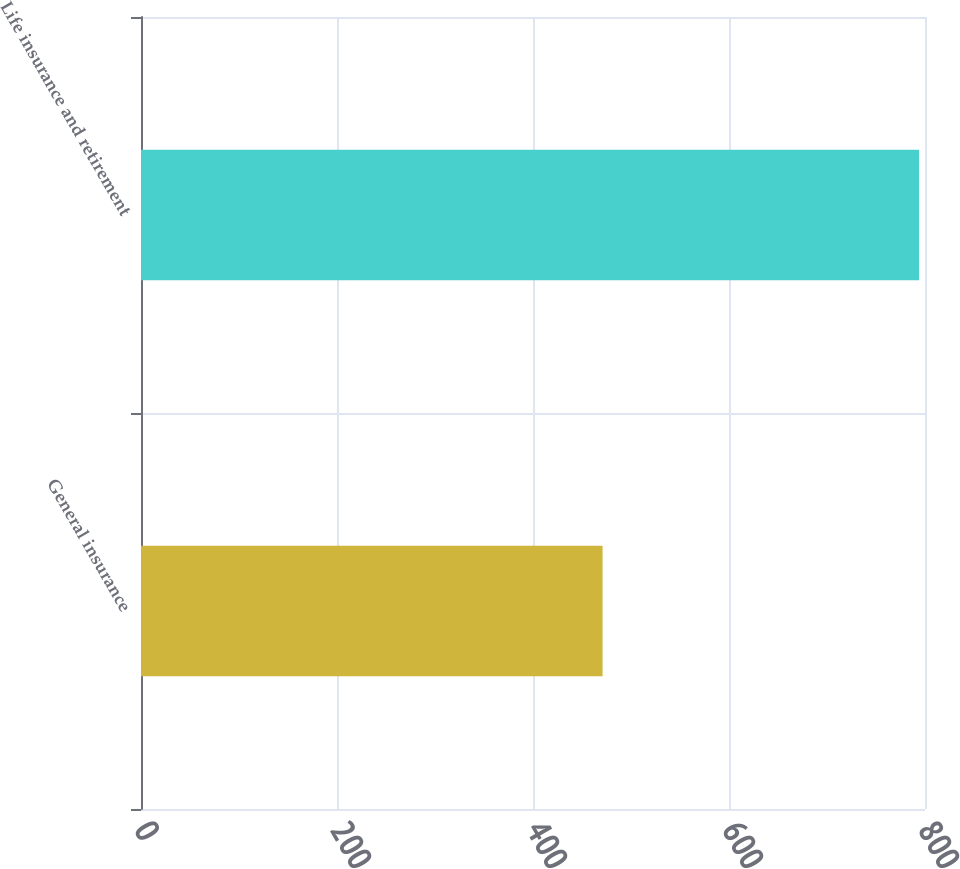Convert chart. <chart><loc_0><loc_0><loc_500><loc_500><bar_chart><fcel>General insurance<fcel>Life insurance and retirement<nl><fcel>471<fcel>794<nl></chart> 